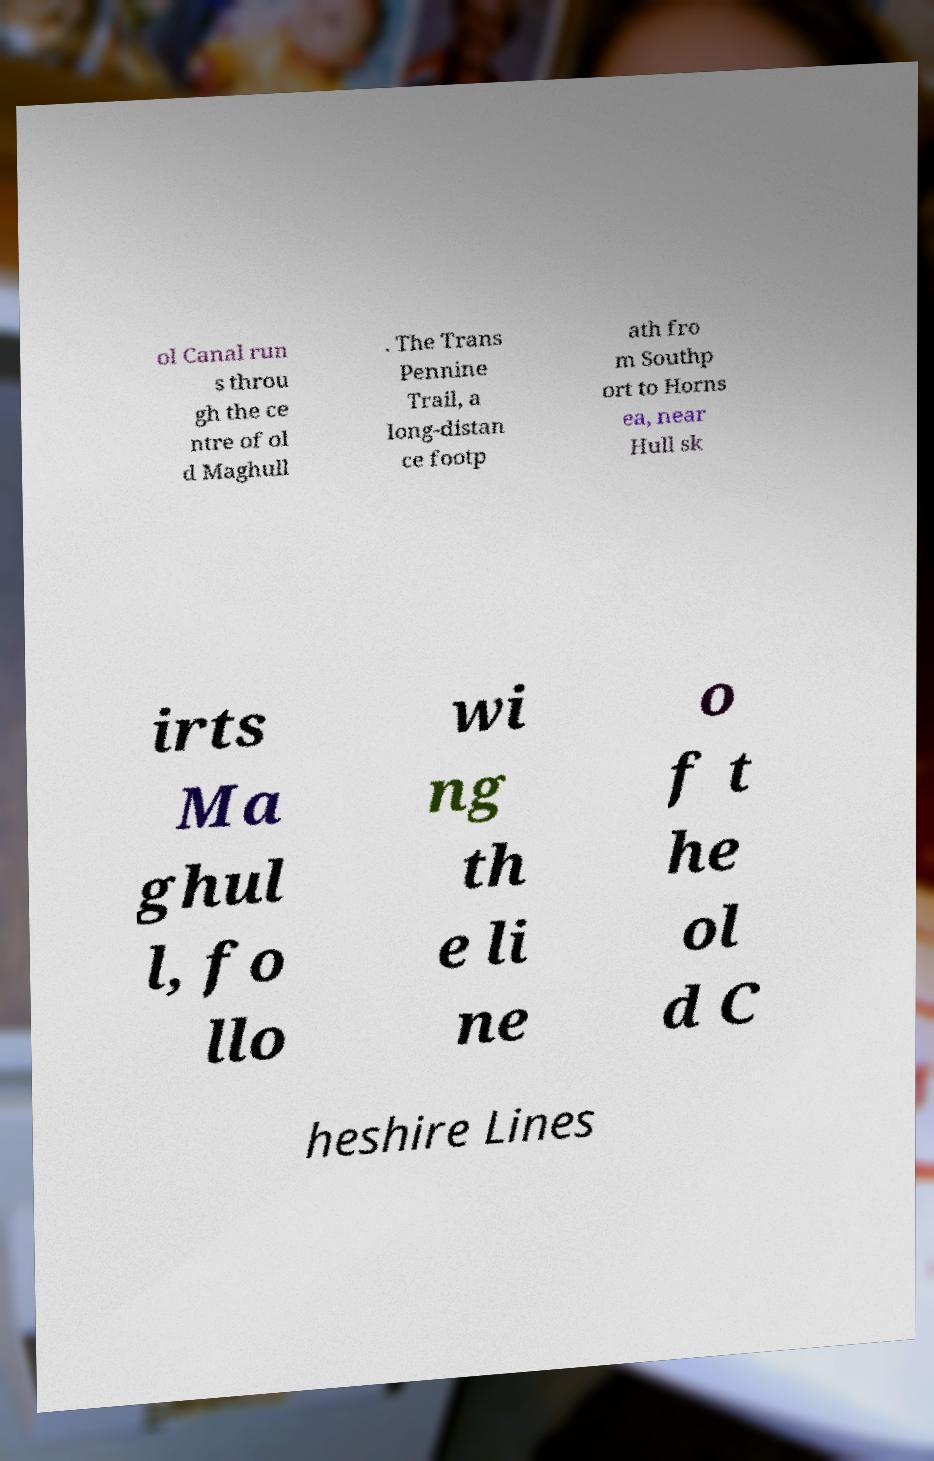Can you read and provide the text displayed in the image?This photo seems to have some interesting text. Can you extract and type it out for me? ol Canal run s throu gh the ce ntre of ol d Maghull . The Trans Pennine Trail, a long-distan ce footp ath fro m Southp ort to Horns ea, near Hull sk irts Ma ghul l, fo llo wi ng th e li ne o f t he ol d C heshire Lines 